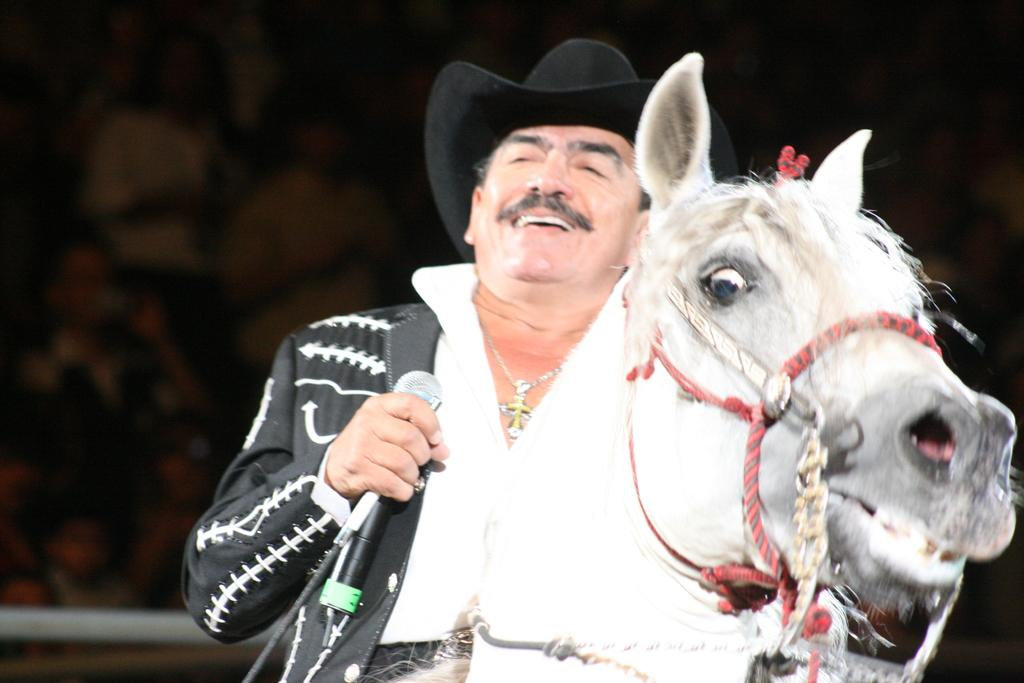What is the main subject of the image? The main subject of the image is a man. What is the man doing in the image? The man is sitting on a horse and holding a microphone in his hands. What is the man's facial expression in the image? The man is smiling in the image. What type of wave can be seen in the image? There is no wave present in the image. What color is the ring on the man's finger in the image? The man is not wearing a ring in the image. 